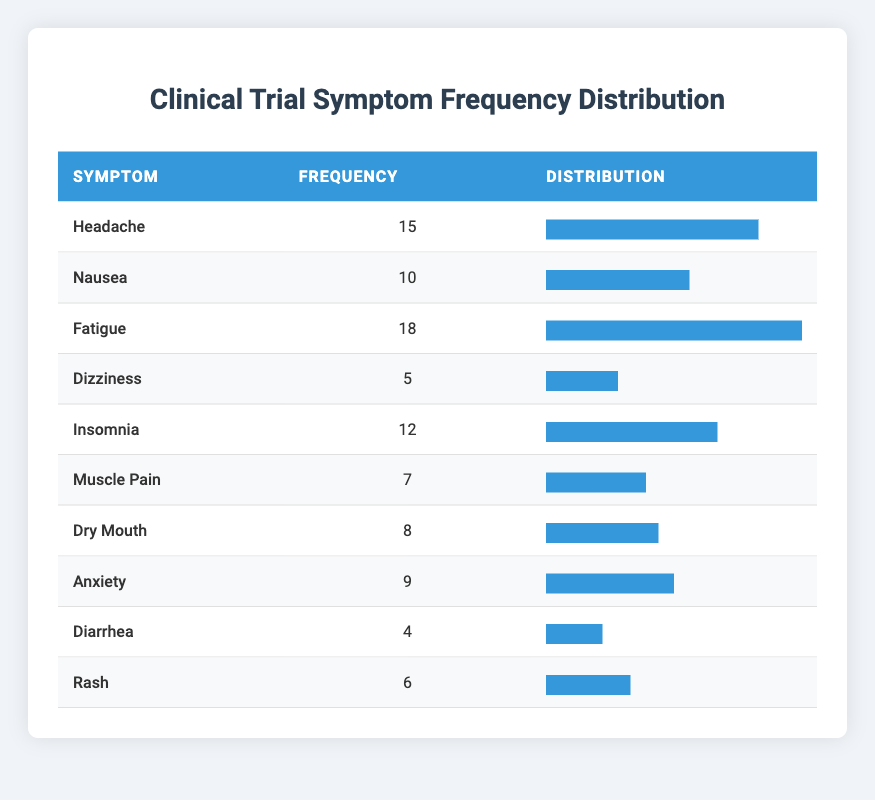What is the most frequently reported symptom? From the table, the symptom with the highest frequency is "Fatigue," which has a frequency of 18.
Answer: Fatigue How many patients reported experiencing either Nausea or Muscle Pain? The frequency for Nausea is 10 and for Muscle Pain is 7. To find the total, we sum these two values: 10 + 7 = 17.
Answer: 17 Is there a symptom that was reported by more than 15 patients? Yes, "Fatigue" is reported by 18 patients, which is greater than 15.
Answer: Yes What is the total frequency of all the symptoms combined? To find this, we sum the frequencies of all symptoms: 15 + 10 + 18 + 5 + 12 + 7 + 8 + 9 + 4 + 6 = 105.
Answer: 105 What is the difference in frequency between the most and least reported symptoms? The most reported symptom, "Fatigue," has a frequency of 18, while the least reported symptom, "Diarrhea," has a frequency of 4. The difference is 18 - 4 = 14.
Answer: 14 How many symptoms have a frequency greater than or equal to 10? The symptoms with a frequency of 10 or more are: Headache (15), Nausea (10), Fatigue (18), Insomnia (12), and Anxiety (9). This totals to 5 symptoms.
Answer: 5 What is the average frequency of the symptoms listed? The total frequency is 105 and there are 10 symptoms, so the average frequency is 105 / 10 = 10.5.
Answer: 10.5 Which symptom has a frequency closest to the average frequency for the symptoms? The average frequency is 10.5. The symptoms with frequencies closest to this value are Nausea (10) and Insomnia (12).
Answer: Nausea and Insomnia How many symptoms have a frequency less than 8? The symptoms with a frequency less than 8 are Diarrhea (4) and Muscle Pain (7), totaling 2 symptoms.
Answer: 2 